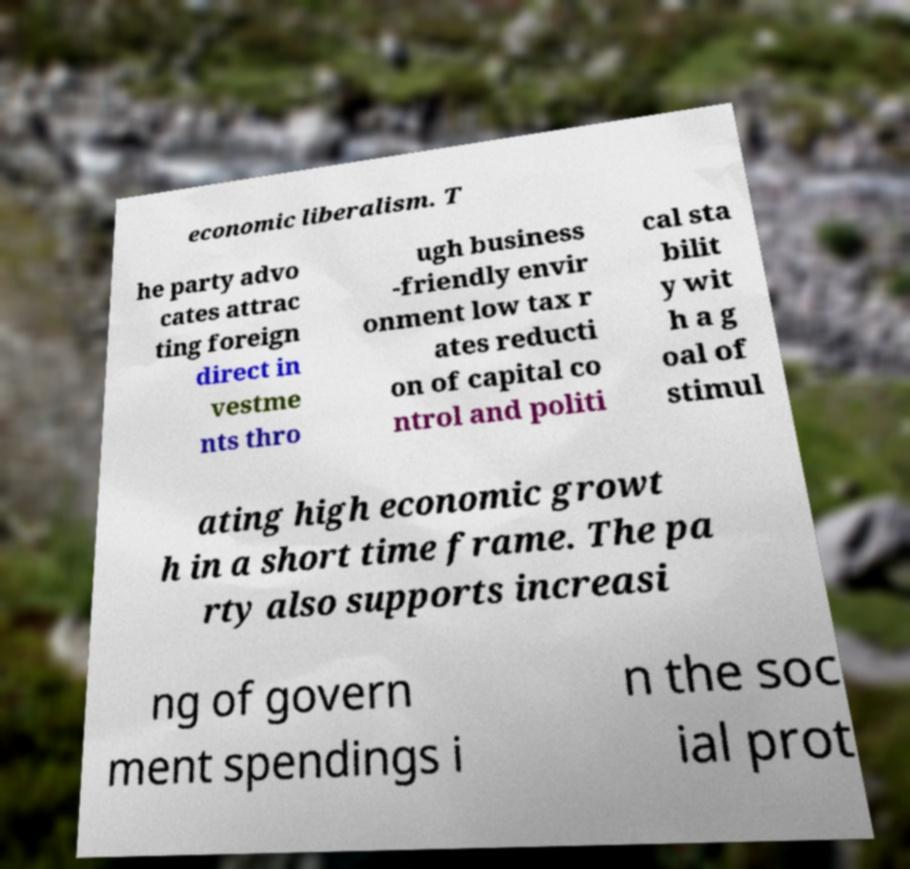Could you assist in decoding the text presented in this image and type it out clearly? economic liberalism. T he party advo cates attrac ting foreign direct in vestme nts thro ugh business -friendly envir onment low tax r ates reducti on of capital co ntrol and politi cal sta bilit y wit h a g oal of stimul ating high economic growt h in a short time frame. The pa rty also supports increasi ng of govern ment spendings i n the soc ial prot 